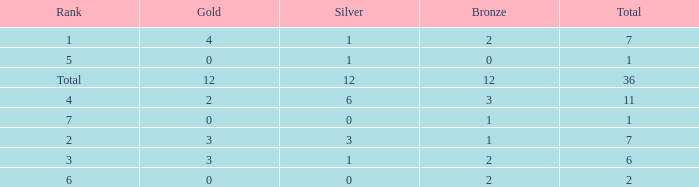What is the largest total for a team with 1 bronze, 0 gold medals and ranking of 7? None. Write the full table. {'header': ['Rank', 'Gold', 'Silver', 'Bronze', 'Total'], 'rows': [['1', '4', '1', '2', '7'], ['5', '0', '1', '0', '1'], ['Total', '12', '12', '12', '36'], ['4', '2', '6', '3', '11'], ['7', '0', '0', '1', '1'], ['2', '3', '3', '1', '7'], ['3', '3', '1', '2', '6'], ['6', '0', '0', '2', '2']]} 